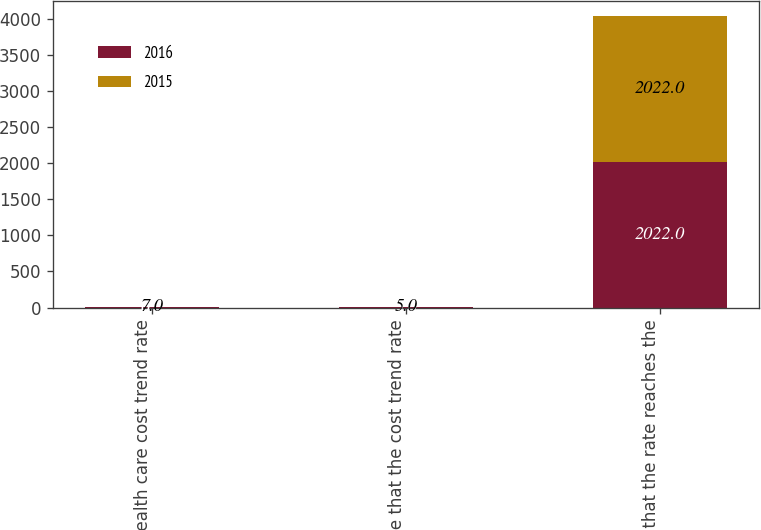Convert chart. <chart><loc_0><loc_0><loc_500><loc_500><stacked_bar_chart><ecel><fcel>Health care cost trend rate<fcel>Rate that the cost trend rate<fcel>Year that the rate reaches the<nl><fcel>2016<fcel>6.5<fcel>5<fcel>2022<nl><fcel>2015<fcel>7<fcel>5<fcel>2022<nl></chart> 